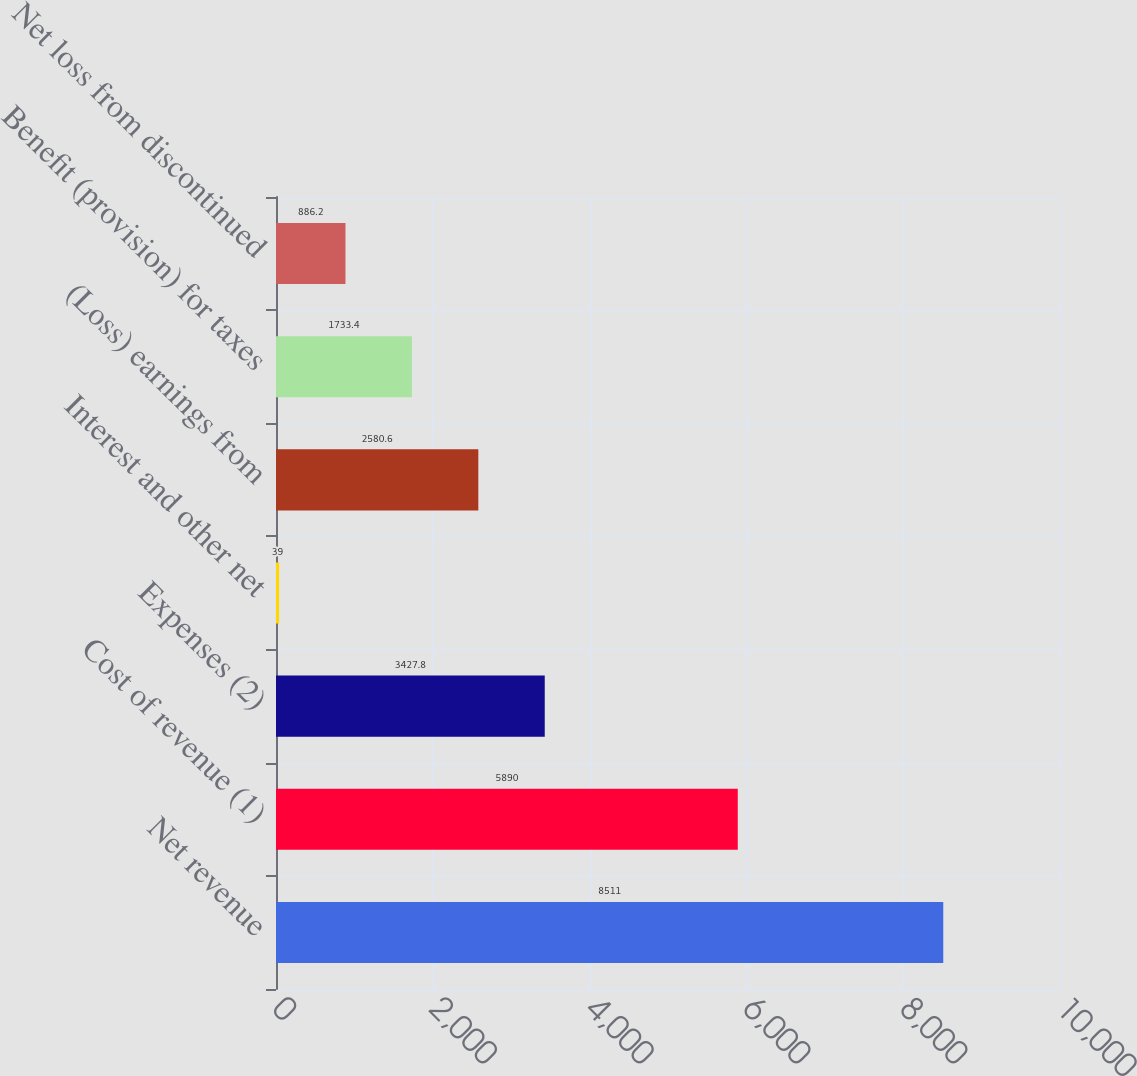Convert chart to OTSL. <chart><loc_0><loc_0><loc_500><loc_500><bar_chart><fcel>Net revenue<fcel>Cost of revenue (1)<fcel>Expenses (2)<fcel>Interest and other net<fcel>(Loss) earnings from<fcel>Benefit (provision) for taxes<fcel>Net loss from discontinued<nl><fcel>8511<fcel>5890<fcel>3427.8<fcel>39<fcel>2580.6<fcel>1733.4<fcel>886.2<nl></chart> 